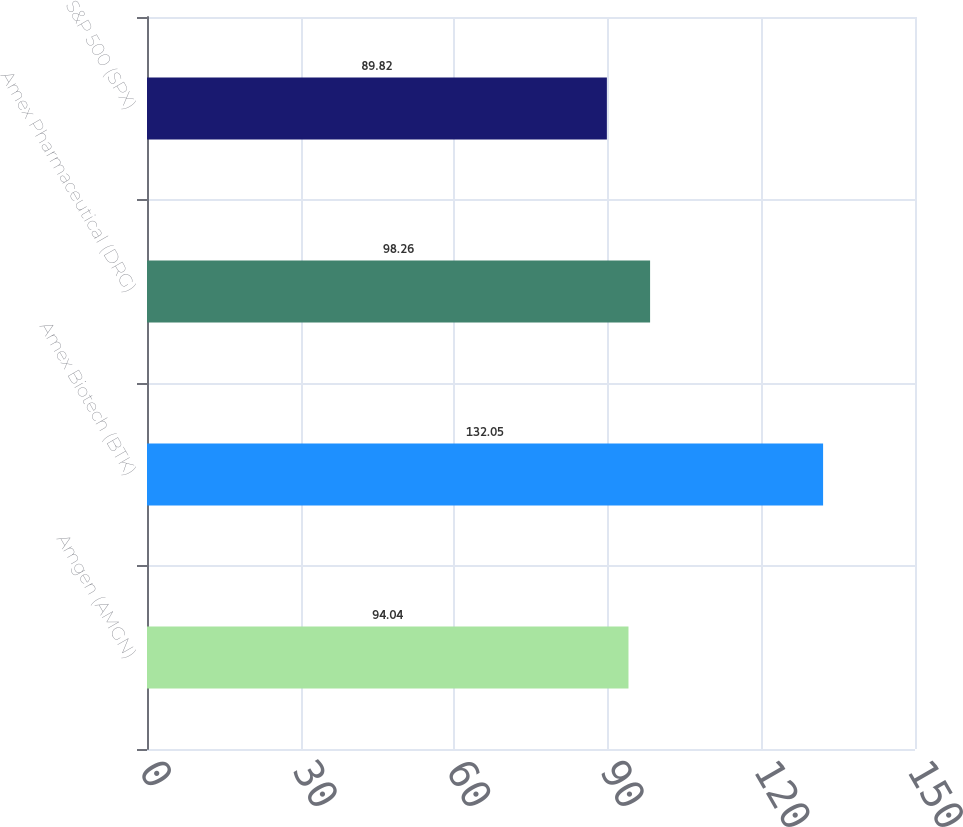Convert chart to OTSL. <chart><loc_0><loc_0><loc_500><loc_500><bar_chart><fcel>Amgen (AMGN)<fcel>Amex Biotech (BTK)<fcel>Amex Pharmaceutical (DRG)<fcel>S&P 500 (SPX)<nl><fcel>94.04<fcel>132.05<fcel>98.26<fcel>89.82<nl></chart> 